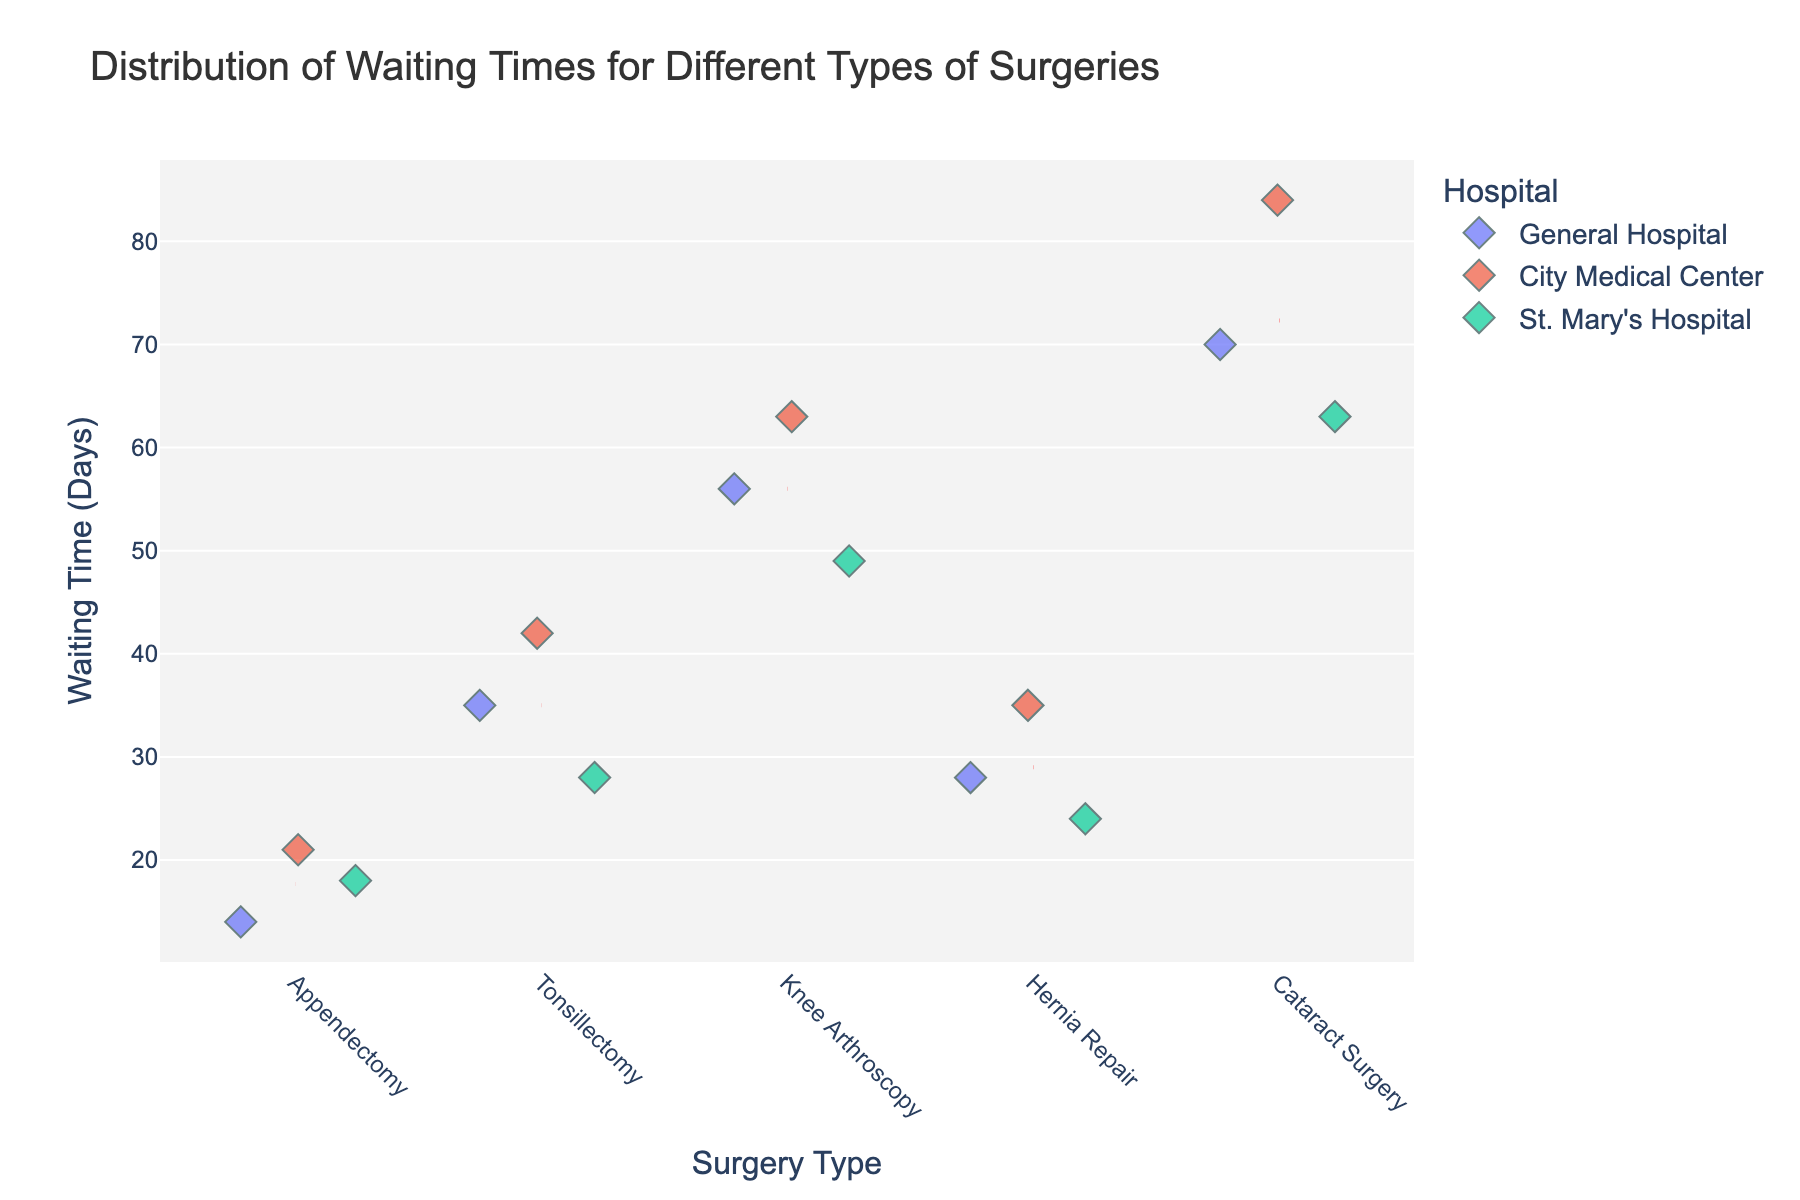What's the title of the plot? The title of the plot is located at the top and usually summarizes the content of the plot.
Answer: Distribution of Waiting Times for Different Types of Surgeries How many hospitals are represented in the plot? By looking at the legend or the different colors in the plot, we can see that there are three different hospitals.
Answer: 3 Which surgery type has the highest average waiting time? The average waiting time can be inferred by looking at the red dashed lines for each surgery type. The highest line indicates the highest average waiting time. Cataract Surgery has the highest red dashed line.
Answer: Cataract Surgery What's the shortest waiting time for Appendectomy at City Medical Center? Locate the points corresponding to the City Medical Center for Appendectomy on the y-axis; the lowest point indicates the shortest waiting time.
Answer: 21 days What's the range of waiting times for Tonsillectomy at different hospitals? Find the highest and lowest points for Tonsillectomy and calculate the difference. The highest is 42 (City Medical Center) and the lowest is 28 (St. Mary's Hospital).
Answer: 14 days Which hospital has the most patients waiting for Hernia Repair? Count the number of points (data points) for each hospital under the Hernia Repair category. Each hospital has an equal number of data points, which is one each.
Answer: Equal (1 each) For which surgery type does General Hospital have the longest waiting time? Compare the y-values (waiting times) for all surgery types at General Hospital (blue markers). Cataract Surgery has the longest waiting time.
Answer: Cataract Surgery What's the difference in average waiting times for Knee Arthroscopy between General Hospital and St. Mary's Hospital? Identify the red dashed lines for Knee Arthroscopy at General Hospital and St. Mary's Hospital and calculate the difference. Average waiting times are approximately 56 (General Hospital) and 49 (St. Mary's Hospital), so the difference is 56 - 49.
Answer: 7 days What's the average waiting time for Hernia Repair? Calculate the average by summing up the waiting times for Hernia Repair (28 + 35 + 24) and divide by the number of data points (3). The sum is 87, divided by 3 is 29.
Answer: 29 days Which hospital has the shortest average waiting time across all surgery types? Look at the red dashed lines representing average waiting times for each hospital across all surgery types and identify the lowest overall average. St. Mary's Hospital consistently has lower lines compared to the others.
Answer: St. Mary's Hospital 